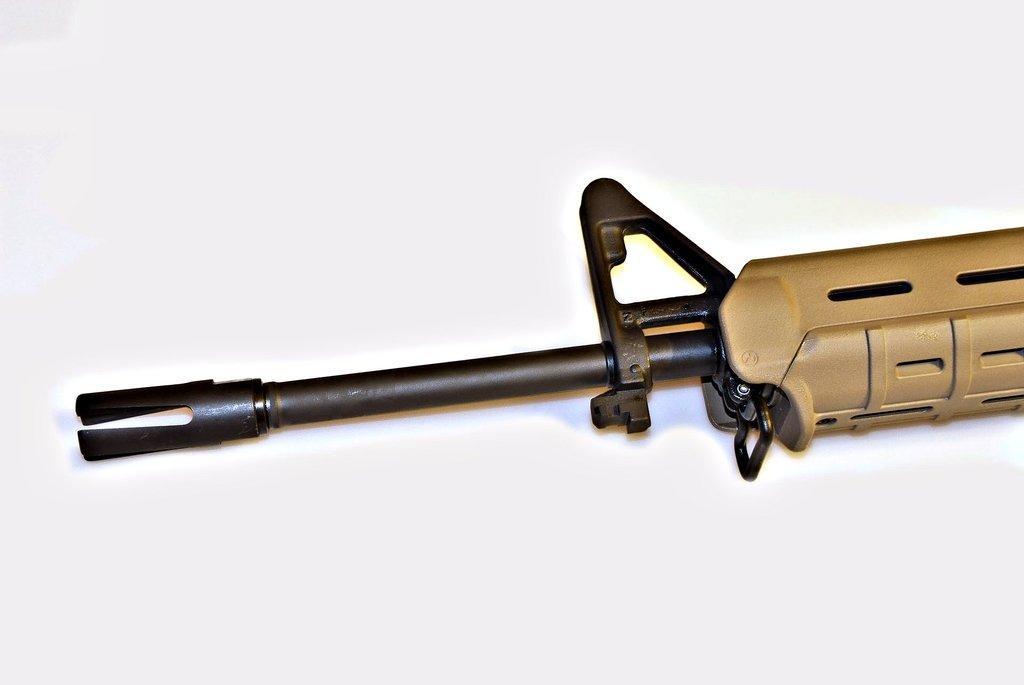Describe this image in one or two sentences. In this image I can see truncated picture of a gun. I can also see white colour in the background. 